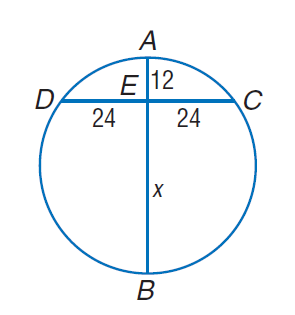Answer the mathemtical geometry problem and directly provide the correct option letter.
Question: Find A B.
Choices: A: 12 B: 24 C: 48 D: 60 D 